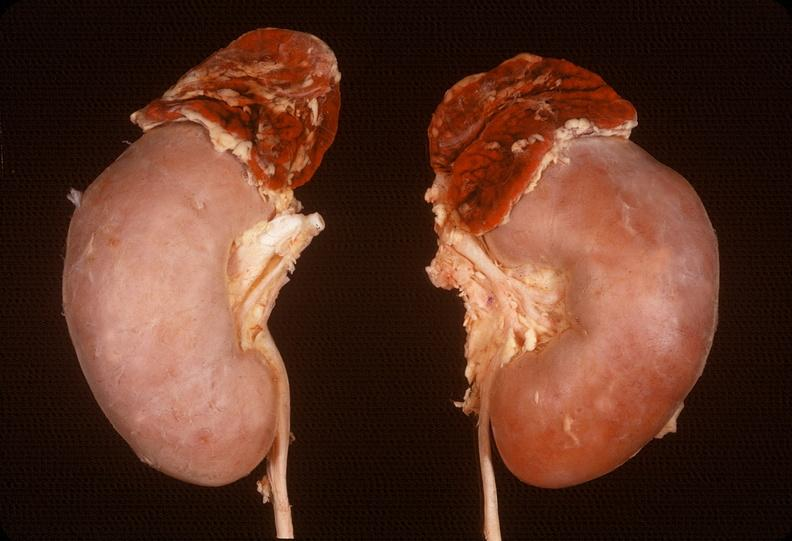where does this belong to?
Answer the question using a single word or phrase. Endocrine system 